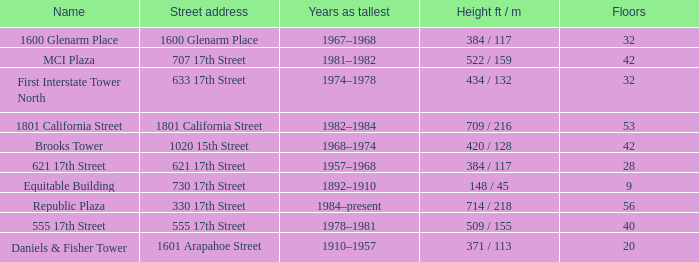What is the height of the building named 555 17th street? 509 / 155. 